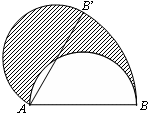What geometric concept might the shaded area represent in this diagram? The shaded area in the diagram likely represents a segment of the semicircle, which is a region bounded by a chord and the arc it subtends. In this case, the chord is the line from B to B', and the arc is the portion of the semicircle's circumference between these two points. The area could be used to explore concepts such as segment area calculation, or to demonstrate properties like the segment's relationship with the corresponding sector area, which includes the triangle ABB'. 